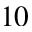<formula> <loc_0><loc_0><loc_500><loc_500>1 0</formula> 